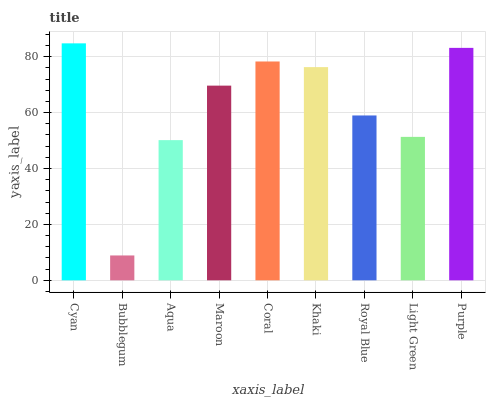Is Bubblegum the minimum?
Answer yes or no. Yes. Is Cyan the maximum?
Answer yes or no. Yes. Is Aqua the minimum?
Answer yes or no. No. Is Aqua the maximum?
Answer yes or no. No. Is Aqua greater than Bubblegum?
Answer yes or no. Yes. Is Bubblegum less than Aqua?
Answer yes or no. Yes. Is Bubblegum greater than Aqua?
Answer yes or no. No. Is Aqua less than Bubblegum?
Answer yes or no. No. Is Maroon the high median?
Answer yes or no. Yes. Is Maroon the low median?
Answer yes or no. Yes. Is Bubblegum the high median?
Answer yes or no. No. Is Light Green the low median?
Answer yes or no. No. 